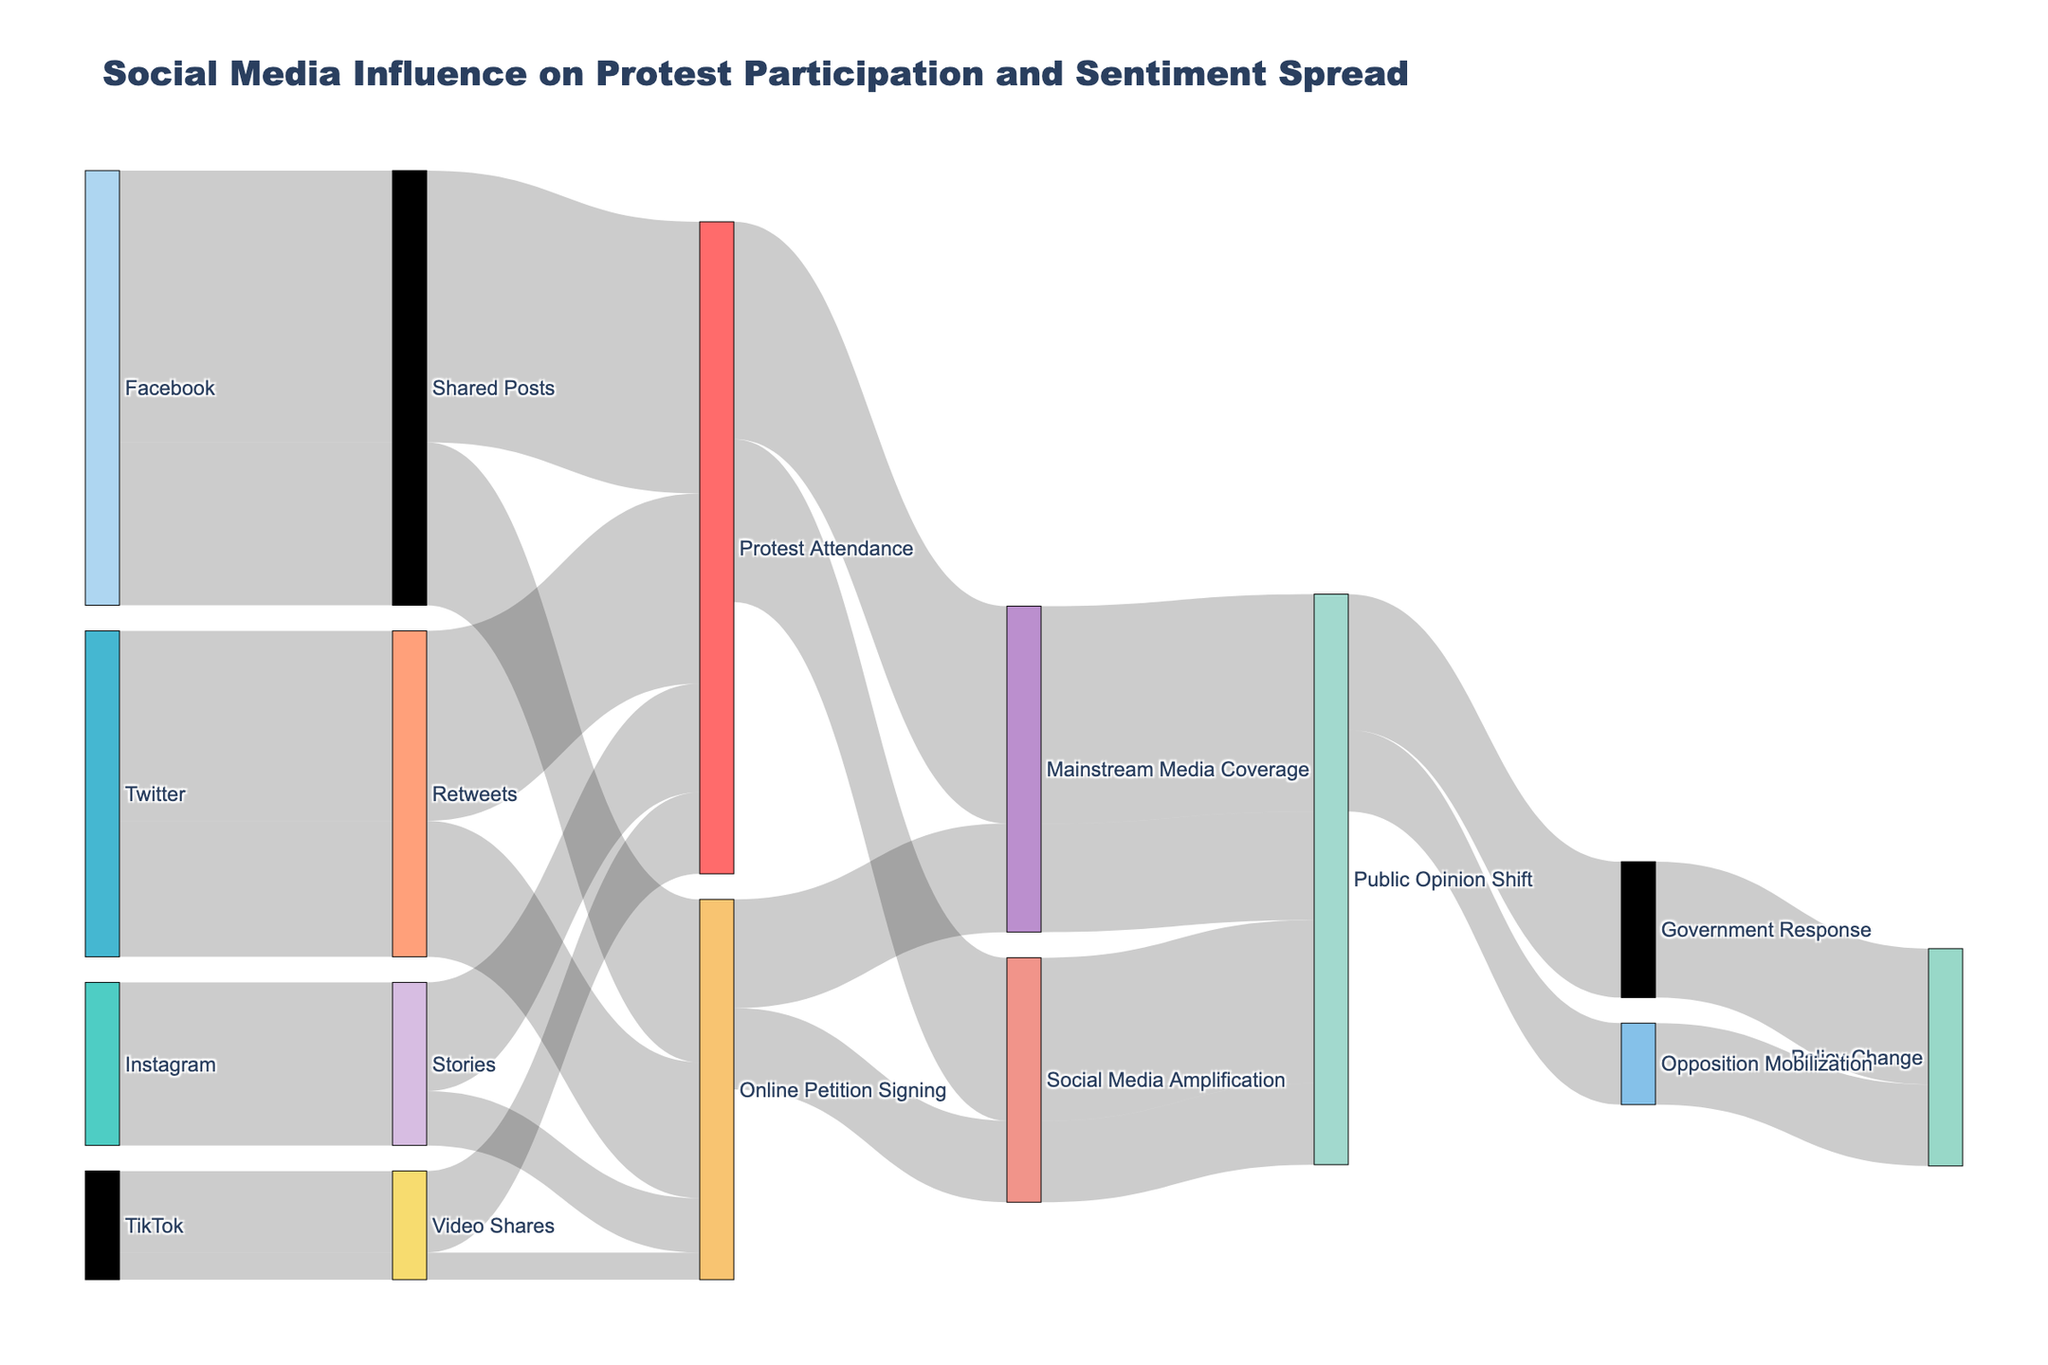What's the title of the figure? The title is displayed at the top of the figure in a larger font size. It provides an overview of what the diagram represents.
Answer: Social Media Influence on Protest Participation and Sentiment Spread How many social media platforms are included in the diagram? By looking at the sources on the left side of the figure, we can count the distinct social media platforms.
Answer: 4 Which social media platform has the highest influence on protest attendance? By comparing the values linked to "Protest Attendance" from each social media platform, we can identify the one with the highest number.
Answer: Facebook What is the combined value of Twitter's influence on protest attendance and online petition signing? We need to sum the value from Twitter to "Protest Attendance" and "Online Petition Signing". This is 3500 (Protest Attendance) + 2500 (Online Petition Signing).
Answer: 6000 Which intermediate step has the least influence on public opinion shift? By comparing the values from each intermediate step to "Public Opinion Shift," we can identify the one with the smallest number.
Answer: Online Petition Signing via Social Media Amplification What is the total value of the flows from "Public Opinion Shift" to "Policy Change"? We add the values of "Public Opinion Shift" leading to "Government Response" and "Opposition Mobilization". This is 2500 (Government Response) + 1500 (Opposition Mobilization).
Answer: 4000 Which has a greater influence on public opinion shift: mainstream media coverage or social media amplification? We compare the total values from "Mainstream Media Coverage" to "Public Opinion Shift" and "Social Media Amplification" to "Public Opinion Shift".
Answer: Mainstream Media Coverage What is the value difference between "Protest Attendance" and "Online Petition Signing" in influencing public opinion shift? We subtract the total value of "Online Petition Signing" from "Protest Attendance" affecting public opinion shift. (4000 + 3000) - (2000 + 1500) = 9500 - 3500
Answer: 6000 How does the influence of Facebook on protest attendance compare to that of TikTok? We compare the values directly linked to "Protest Attendance" from Facebook and TikTok.
Answer: Facebook has more influence 